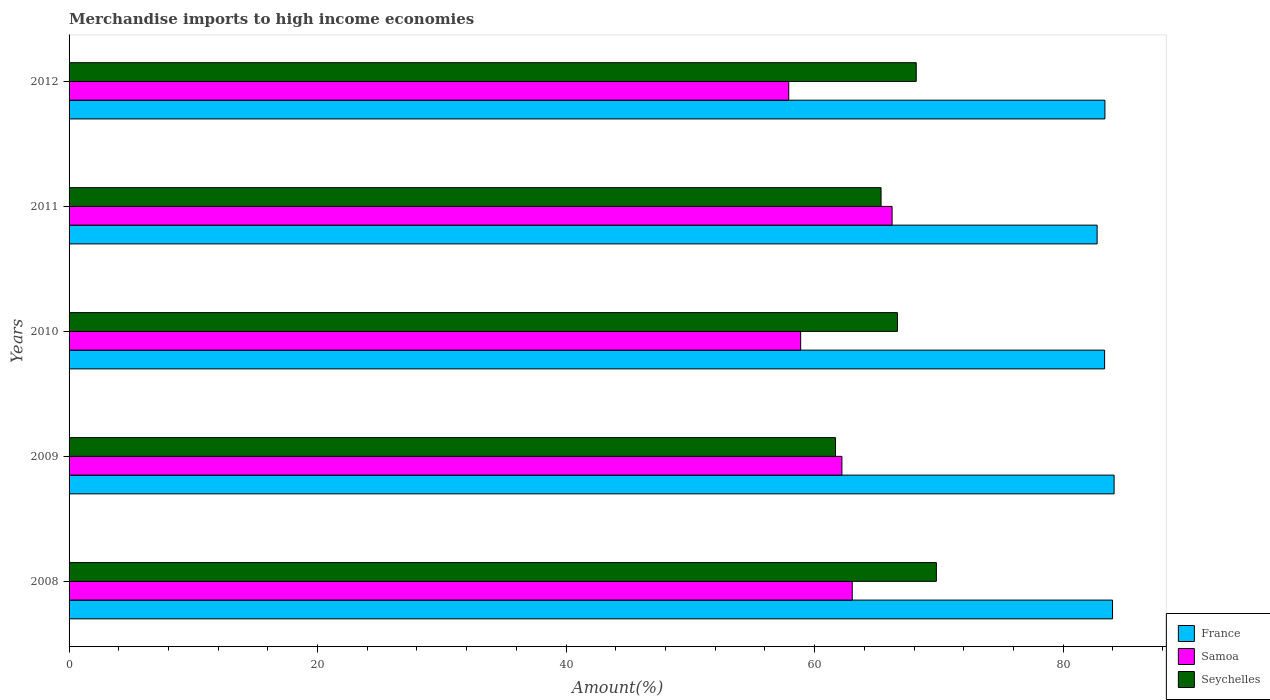How many different coloured bars are there?
Give a very brief answer. 3. How many groups of bars are there?
Ensure brevity in your answer.  5. Are the number of bars on each tick of the Y-axis equal?
Give a very brief answer. Yes. How many bars are there on the 5th tick from the top?
Your answer should be very brief. 3. How many bars are there on the 5th tick from the bottom?
Keep it short and to the point. 3. In how many cases, is the number of bars for a given year not equal to the number of legend labels?
Your answer should be compact. 0. What is the percentage of amount earned from merchandise imports in Seychelles in 2009?
Offer a very short reply. 61.68. Across all years, what is the maximum percentage of amount earned from merchandise imports in Samoa?
Provide a succinct answer. 66.23. Across all years, what is the minimum percentage of amount earned from merchandise imports in France?
Provide a short and direct response. 82.74. In which year was the percentage of amount earned from merchandise imports in Seychelles maximum?
Keep it short and to the point. 2008. What is the total percentage of amount earned from merchandise imports in France in the graph?
Provide a short and direct response. 417.52. What is the difference between the percentage of amount earned from merchandise imports in France in 2008 and that in 2012?
Ensure brevity in your answer.  0.61. What is the difference between the percentage of amount earned from merchandise imports in Seychelles in 2010 and the percentage of amount earned from merchandise imports in Samoa in 2011?
Your answer should be compact. 0.43. What is the average percentage of amount earned from merchandise imports in Samoa per year?
Ensure brevity in your answer.  61.65. In the year 2011, what is the difference between the percentage of amount earned from merchandise imports in Seychelles and percentage of amount earned from merchandise imports in France?
Make the answer very short. -17.39. What is the ratio of the percentage of amount earned from merchandise imports in Samoa in 2009 to that in 2010?
Keep it short and to the point. 1.06. What is the difference between the highest and the second highest percentage of amount earned from merchandise imports in Seychelles?
Your answer should be very brief. 1.62. What is the difference between the highest and the lowest percentage of amount earned from merchandise imports in Samoa?
Your response must be concise. 8.32. What does the 1st bar from the top in 2012 represents?
Offer a terse response. Seychelles. What does the 2nd bar from the bottom in 2008 represents?
Make the answer very short. Samoa. How many years are there in the graph?
Offer a very short reply. 5. What is the difference between two consecutive major ticks on the X-axis?
Make the answer very short. 20. Are the values on the major ticks of X-axis written in scientific E-notation?
Your response must be concise. No. Does the graph contain any zero values?
Offer a terse response. No. How are the legend labels stacked?
Your answer should be compact. Vertical. What is the title of the graph?
Provide a succinct answer. Merchandise imports to high income economies. What is the label or title of the X-axis?
Provide a succinct answer. Amount(%). What is the Amount(%) of France in 2008?
Your answer should be compact. 83.98. What is the Amount(%) of Samoa in 2008?
Provide a succinct answer. 63.03. What is the Amount(%) in Seychelles in 2008?
Provide a succinct answer. 69.8. What is the Amount(%) in France in 2009?
Provide a short and direct response. 84.1. What is the Amount(%) of Samoa in 2009?
Your answer should be compact. 62.2. What is the Amount(%) of Seychelles in 2009?
Give a very brief answer. 61.68. What is the Amount(%) in France in 2010?
Ensure brevity in your answer.  83.34. What is the Amount(%) in Samoa in 2010?
Ensure brevity in your answer.  58.88. What is the Amount(%) in Seychelles in 2010?
Offer a very short reply. 66.66. What is the Amount(%) in France in 2011?
Provide a short and direct response. 82.74. What is the Amount(%) of Samoa in 2011?
Keep it short and to the point. 66.23. What is the Amount(%) in Seychelles in 2011?
Your response must be concise. 65.35. What is the Amount(%) in France in 2012?
Offer a very short reply. 83.36. What is the Amount(%) in Samoa in 2012?
Offer a terse response. 57.92. What is the Amount(%) of Seychelles in 2012?
Offer a terse response. 68.18. Across all years, what is the maximum Amount(%) of France?
Offer a very short reply. 84.1. Across all years, what is the maximum Amount(%) in Samoa?
Ensure brevity in your answer.  66.23. Across all years, what is the maximum Amount(%) of Seychelles?
Your answer should be very brief. 69.8. Across all years, what is the minimum Amount(%) in France?
Your response must be concise. 82.74. Across all years, what is the minimum Amount(%) of Samoa?
Ensure brevity in your answer.  57.92. Across all years, what is the minimum Amount(%) in Seychelles?
Provide a short and direct response. 61.68. What is the total Amount(%) of France in the graph?
Make the answer very short. 417.52. What is the total Amount(%) of Samoa in the graph?
Ensure brevity in your answer.  308.26. What is the total Amount(%) in Seychelles in the graph?
Make the answer very short. 331.67. What is the difference between the Amount(%) in France in 2008 and that in 2009?
Make the answer very short. -0.13. What is the difference between the Amount(%) in Samoa in 2008 and that in 2009?
Offer a terse response. 0.83. What is the difference between the Amount(%) of Seychelles in 2008 and that in 2009?
Your answer should be compact. 8.12. What is the difference between the Amount(%) in France in 2008 and that in 2010?
Ensure brevity in your answer.  0.64. What is the difference between the Amount(%) in Samoa in 2008 and that in 2010?
Provide a short and direct response. 4.15. What is the difference between the Amount(%) in Seychelles in 2008 and that in 2010?
Keep it short and to the point. 3.14. What is the difference between the Amount(%) in France in 2008 and that in 2011?
Give a very brief answer. 1.24. What is the difference between the Amount(%) in Samoa in 2008 and that in 2011?
Provide a short and direct response. -3.21. What is the difference between the Amount(%) of Seychelles in 2008 and that in 2011?
Offer a very short reply. 4.45. What is the difference between the Amount(%) of France in 2008 and that in 2012?
Your response must be concise. 0.61. What is the difference between the Amount(%) in Samoa in 2008 and that in 2012?
Your response must be concise. 5.11. What is the difference between the Amount(%) in Seychelles in 2008 and that in 2012?
Your response must be concise. 1.62. What is the difference between the Amount(%) of France in 2009 and that in 2010?
Offer a terse response. 0.76. What is the difference between the Amount(%) of Samoa in 2009 and that in 2010?
Provide a succinct answer. 3.32. What is the difference between the Amount(%) of Seychelles in 2009 and that in 2010?
Offer a very short reply. -4.98. What is the difference between the Amount(%) of France in 2009 and that in 2011?
Provide a succinct answer. 1.37. What is the difference between the Amount(%) of Samoa in 2009 and that in 2011?
Offer a terse response. -4.04. What is the difference between the Amount(%) of Seychelles in 2009 and that in 2011?
Your answer should be compact. -3.66. What is the difference between the Amount(%) in France in 2009 and that in 2012?
Your response must be concise. 0.74. What is the difference between the Amount(%) in Samoa in 2009 and that in 2012?
Offer a terse response. 4.28. What is the difference between the Amount(%) in Seychelles in 2009 and that in 2012?
Your answer should be very brief. -6.5. What is the difference between the Amount(%) of France in 2010 and that in 2011?
Your response must be concise. 0.6. What is the difference between the Amount(%) of Samoa in 2010 and that in 2011?
Keep it short and to the point. -7.36. What is the difference between the Amount(%) in Seychelles in 2010 and that in 2011?
Your answer should be compact. 1.32. What is the difference between the Amount(%) of France in 2010 and that in 2012?
Provide a succinct answer. -0.03. What is the difference between the Amount(%) of Samoa in 2010 and that in 2012?
Ensure brevity in your answer.  0.96. What is the difference between the Amount(%) in Seychelles in 2010 and that in 2012?
Provide a succinct answer. -1.51. What is the difference between the Amount(%) in France in 2011 and that in 2012?
Give a very brief answer. -0.63. What is the difference between the Amount(%) of Samoa in 2011 and that in 2012?
Provide a succinct answer. 8.32. What is the difference between the Amount(%) of Seychelles in 2011 and that in 2012?
Provide a short and direct response. -2.83. What is the difference between the Amount(%) in France in 2008 and the Amount(%) in Samoa in 2009?
Make the answer very short. 21.78. What is the difference between the Amount(%) of France in 2008 and the Amount(%) of Seychelles in 2009?
Offer a very short reply. 22.29. What is the difference between the Amount(%) of Samoa in 2008 and the Amount(%) of Seychelles in 2009?
Ensure brevity in your answer.  1.35. What is the difference between the Amount(%) in France in 2008 and the Amount(%) in Samoa in 2010?
Make the answer very short. 25.1. What is the difference between the Amount(%) in France in 2008 and the Amount(%) in Seychelles in 2010?
Give a very brief answer. 17.31. What is the difference between the Amount(%) in Samoa in 2008 and the Amount(%) in Seychelles in 2010?
Ensure brevity in your answer.  -3.64. What is the difference between the Amount(%) of France in 2008 and the Amount(%) of Samoa in 2011?
Provide a short and direct response. 17.74. What is the difference between the Amount(%) in France in 2008 and the Amount(%) in Seychelles in 2011?
Provide a succinct answer. 18.63. What is the difference between the Amount(%) in Samoa in 2008 and the Amount(%) in Seychelles in 2011?
Offer a terse response. -2.32. What is the difference between the Amount(%) of France in 2008 and the Amount(%) of Samoa in 2012?
Keep it short and to the point. 26.06. What is the difference between the Amount(%) in France in 2008 and the Amount(%) in Seychelles in 2012?
Make the answer very short. 15.8. What is the difference between the Amount(%) in Samoa in 2008 and the Amount(%) in Seychelles in 2012?
Your answer should be very brief. -5.15. What is the difference between the Amount(%) in France in 2009 and the Amount(%) in Samoa in 2010?
Provide a succinct answer. 25.23. What is the difference between the Amount(%) of France in 2009 and the Amount(%) of Seychelles in 2010?
Provide a succinct answer. 17.44. What is the difference between the Amount(%) in Samoa in 2009 and the Amount(%) in Seychelles in 2010?
Ensure brevity in your answer.  -4.47. What is the difference between the Amount(%) of France in 2009 and the Amount(%) of Samoa in 2011?
Your answer should be very brief. 17.87. What is the difference between the Amount(%) of France in 2009 and the Amount(%) of Seychelles in 2011?
Give a very brief answer. 18.75. What is the difference between the Amount(%) in Samoa in 2009 and the Amount(%) in Seychelles in 2011?
Give a very brief answer. -3.15. What is the difference between the Amount(%) in France in 2009 and the Amount(%) in Samoa in 2012?
Keep it short and to the point. 26.18. What is the difference between the Amount(%) of France in 2009 and the Amount(%) of Seychelles in 2012?
Provide a succinct answer. 15.92. What is the difference between the Amount(%) in Samoa in 2009 and the Amount(%) in Seychelles in 2012?
Keep it short and to the point. -5.98. What is the difference between the Amount(%) of France in 2010 and the Amount(%) of Samoa in 2011?
Your answer should be compact. 17.1. What is the difference between the Amount(%) in France in 2010 and the Amount(%) in Seychelles in 2011?
Your answer should be very brief. 17.99. What is the difference between the Amount(%) in Samoa in 2010 and the Amount(%) in Seychelles in 2011?
Your response must be concise. -6.47. What is the difference between the Amount(%) of France in 2010 and the Amount(%) of Samoa in 2012?
Give a very brief answer. 25.42. What is the difference between the Amount(%) in France in 2010 and the Amount(%) in Seychelles in 2012?
Provide a succinct answer. 15.16. What is the difference between the Amount(%) in Samoa in 2010 and the Amount(%) in Seychelles in 2012?
Provide a succinct answer. -9.3. What is the difference between the Amount(%) of France in 2011 and the Amount(%) of Samoa in 2012?
Give a very brief answer. 24.82. What is the difference between the Amount(%) in France in 2011 and the Amount(%) in Seychelles in 2012?
Your answer should be compact. 14.56. What is the difference between the Amount(%) of Samoa in 2011 and the Amount(%) of Seychelles in 2012?
Keep it short and to the point. -1.94. What is the average Amount(%) of France per year?
Your response must be concise. 83.5. What is the average Amount(%) in Samoa per year?
Offer a very short reply. 61.65. What is the average Amount(%) in Seychelles per year?
Give a very brief answer. 66.33. In the year 2008, what is the difference between the Amount(%) in France and Amount(%) in Samoa?
Offer a very short reply. 20.95. In the year 2008, what is the difference between the Amount(%) in France and Amount(%) in Seychelles?
Your answer should be very brief. 14.18. In the year 2008, what is the difference between the Amount(%) in Samoa and Amount(%) in Seychelles?
Make the answer very short. -6.77. In the year 2009, what is the difference between the Amount(%) of France and Amount(%) of Samoa?
Your answer should be compact. 21.9. In the year 2009, what is the difference between the Amount(%) of France and Amount(%) of Seychelles?
Offer a very short reply. 22.42. In the year 2009, what is the difference between the Amount(%) of Samoa and Amount(%) of Seychelles?
Make the answer very short. 0.51. In the year 2010, what is the difference between the Amount(%) in France and Amount(%) in Samoa?
Provide a succinct answer. 24.46. In the year 2010, what is the difference between the Amount(%) in France and Amount(%) in Seychelles?
Your response must be concise. 16.67. In the year 2010, what is the difference between the Amount(%) of Samoa and Amount(%) of Seychelles?
Provide a succinct answer. -7.79. In the year 2011, what is the difference between the Amount(%) in France and Amount(%) in Samoa?
Your answer should be very brief. 16.5. In the year 2011, what is the difference between the Amount(%) in France and Amount(%) in Seychelles?
Ensure brevity in your answer.  17.39. In the year 2011, what is the difference between the Amount(%) of Samoa and Amount(%) of Seychelles?
Ensure brevity in your answer.  0.89. In the year 2012, what is the difference between the Amount(%) of France and Amount(%) of Samoa?
Offer a very short reply. 25.44. In the year 2012, what is the difference between the Amount(%) of France and Amount(%) of Seychelles?
Provide a succinct answer. 15.18. In the year 2012, what is the difference between the Amount(%) of Samoa and Amount(%) of Seychelles?
Your answer should be very brief. -10.26. What is the ratio of the Amount(%) in Samoa in 2008 to that in 2009?
Give a very brief answer. 1.01. What is the ratio of the Amount(%) of Seychelles in 2008 to that in 2009?
Your answer should be compact. 1.13. What is the ratio of the Amount(%) of France in 2008 to that in 2010?
Ensure brevity in your answer.  1.01. What is the ratio of the Amount(%) of Samoa in 2008 to that in 2010?
Offer a terse response. 1.07. What is the ratio of the Amount(%) of Seychelles in 2008 to that in 2010?
Your answer should be compact. 1.05. What is the ratio of the Amount(%) in France in 2008 to that in 2011?
Offer a very short reply. 1.01. What is the ratio of the Amount(%) in Samoa in 2008 to that in 2011?
Offer a very short reply. 0.95. What is the ratio of the Amount(%) in Seychelles in 2008 to that in 2011?
Provide a succinct answer. 1.07. What is the ratio of the Amount(%) in France in 2008 to that in 2012?
Your response must be concise. 1.01. What is the ratio of the Amount(%) of Samoa in 2008 to that in 2012?
Provide a succinct answer. 1.09. What is the ratio of the Amount(%) in Seychelles in 2008 to that in 2012?
Keep it short and to the point. 1.02. What is the ratio of the Amount(%) in France in 2009 to that in 2010?
Offer a terse response. 1.01. What is the ratio of the Amount(%) of Samoa in 2009 to that in 2010?
Make the answer very short. 1.06. What is the ratio of the Amount(%) of Seychelles in 2009 to that in 2010?
Provide a succinct answer. 0.93. What is the ratio of the Amount(%) in France in 2009 to that in 2011?
Offer a terse response. 1.02. What is the ratio of the Amount(%) in Samoa in 2009 to that in 2011?
Give a very brief answer. 0.94. What is the ratio of the Amount(%) in Seychelles in 2009 to that in 2011?
Give a very brief answer. 0.94. What is the ratio of the Amount(%) in France in 2009 to that in 2012?
Give a very brief answer. 1.01. What is the ratio of the Amount(%) in Samoa in 2009 to that in 2012?
Your answer should be very brief. 1.07. What is the ratio of the Amount(%) in Seychelles in 2009 to that in 2012?
Give a very brief answer. 0.9. What is the ratio of the Amount(%) of France in 2010 to that in 2011?
Provide a short and direct response. 1.01. What is the ratio of the Amount(%) of Samoa in 2010 to that in 2011?
Provide a short and direct response. 0.89. What is the ratio of the Amount(%) of Seychelles in 2010 to that in 2011?
Make the answer very short. 1.02. What is the ratio of the Amount(%) of France in 2010 to that in 2012?
Keep it short and to the point. 1. What is the ratio of the Amount(%) in Samoa in 2010 to that in 2012?
Give a very brief answer. 1.02. What is the ratio of the Amount(%) in Seychelles in 2010 to that in 2012?
Keep it short and to the point. 0.98. What is the ratio of the Amount(%) in France in 2011 to that in 2012?
Provide a succinct answer. 0.99. What is the ratio of the Amount(%) in Samoa in 2011 to that in 2012?
Your response must be concise. 1.14. What is the ratio of the Amount(%) of Seychelles in 2011 to that in 2012?
Keep it short and to the point. 0.96. What is the difference between the highest and the second highest Amount(%) in France?
Ensure brevity in your answer.  0.13. What is the difference between the highest and the second highest Amount(%) of Samoa?
Offer a very short reply. 3.21. What is the difference between the highest and the second highest Amount(%) in Seychelles?
Offer a very short reply. 1.62. What is the difference between the highest and the lowest Amount(%) in France?
Your answer should be very brief. 1.37. What is the difference between the highest and the lowest Amount(%) of Samoa?
Give a very brief answer. 8.32. What is the difference between the highest and the lowest Amount(%) of Seychelles?
Ensure brevity in your answer.  8.12. 